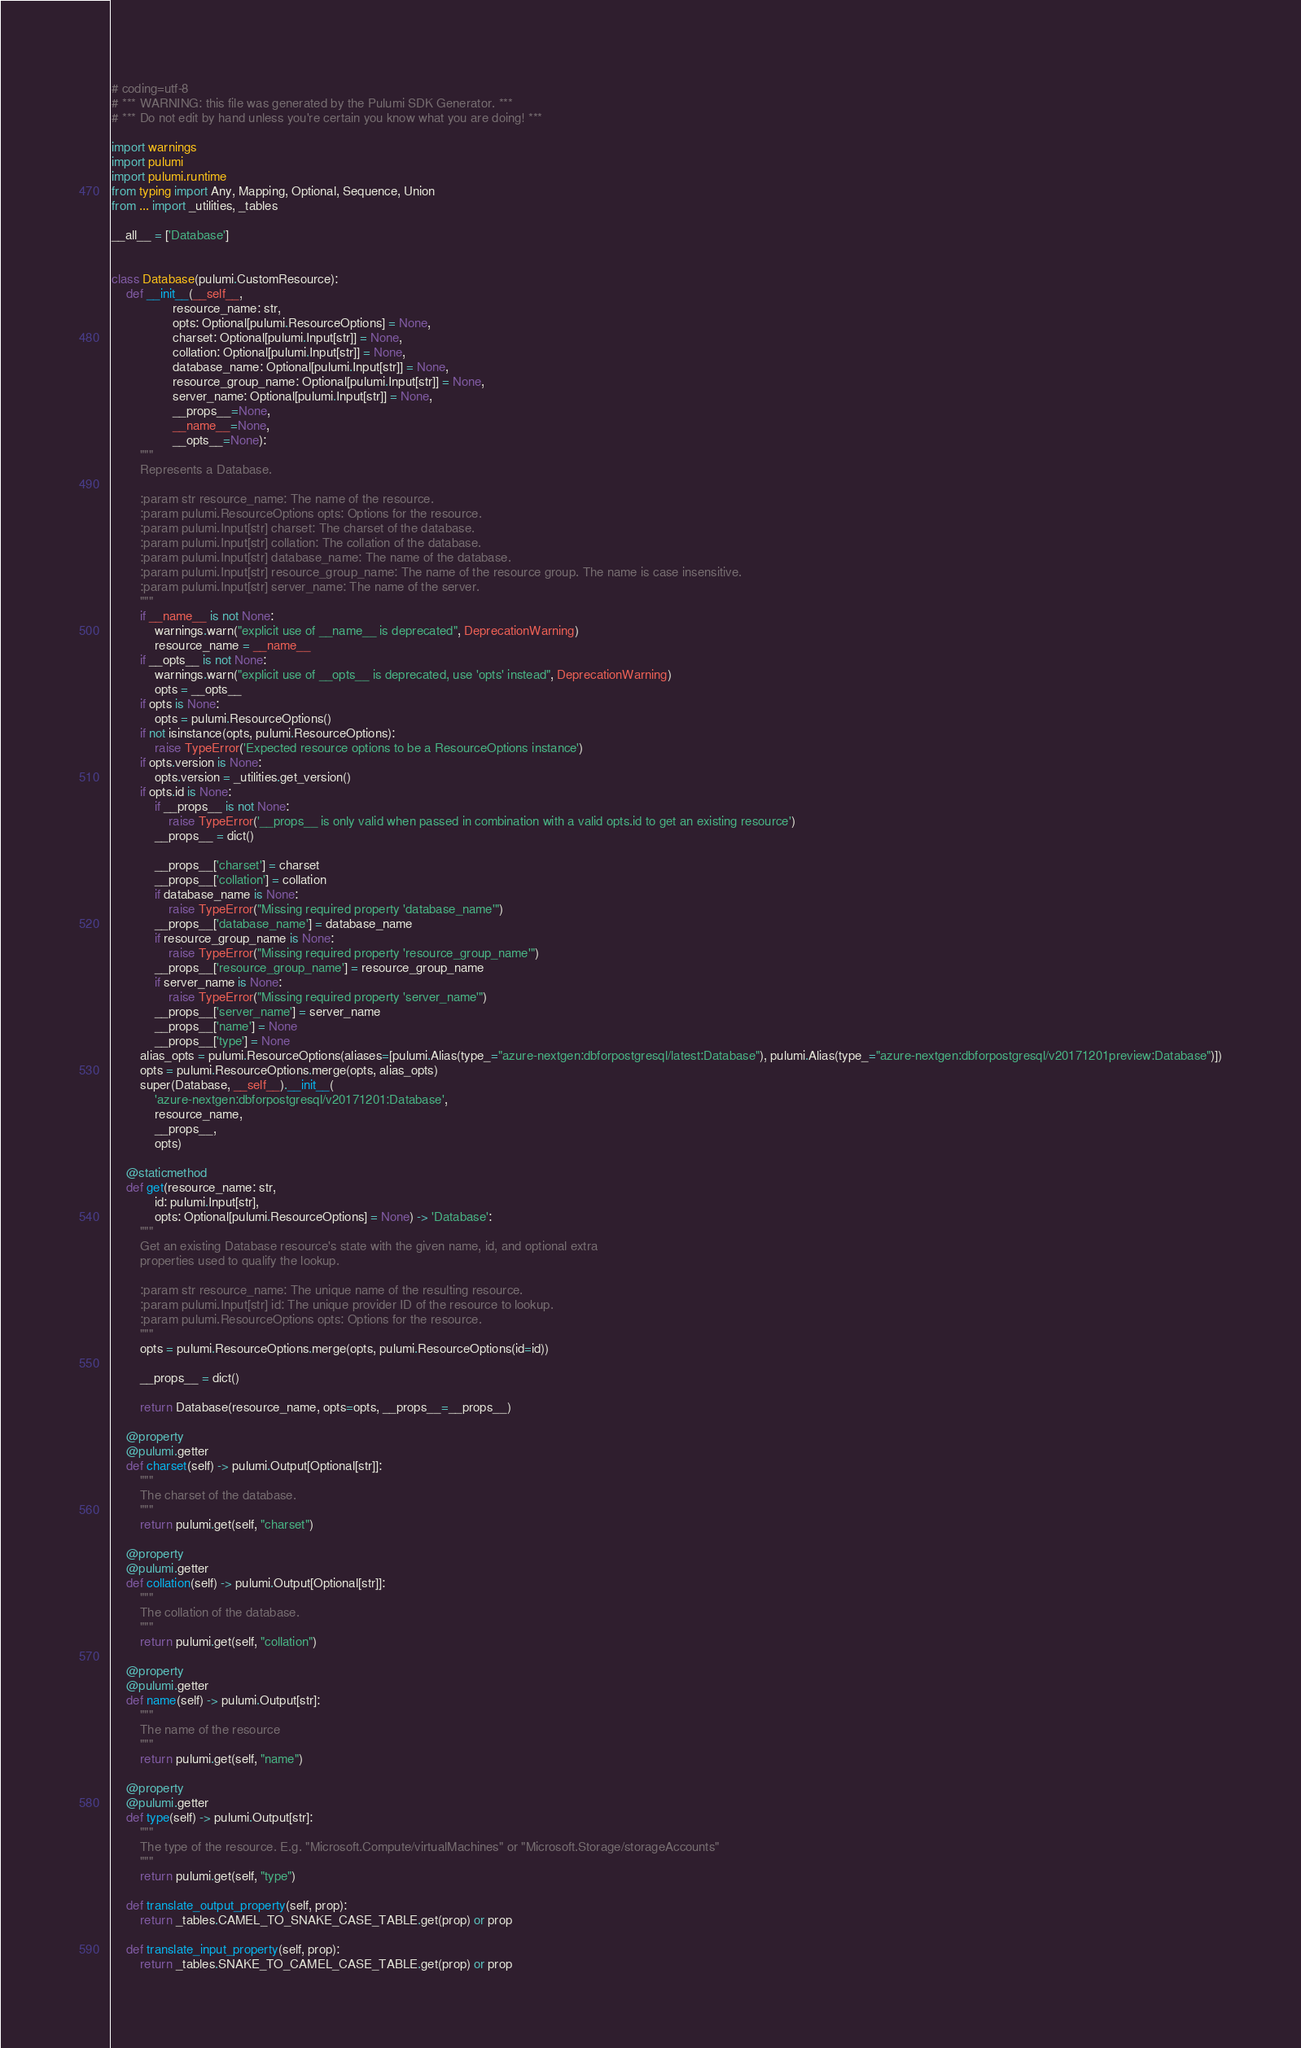<code> <loc_0><loc_0><loc_500><loc_500><_Python_># coding=utf-8
# *** WARNING: this file was generated by the Pulumi SDK Generator. ***
# *** Do not edit by hand unless you're certain you know what you are doing! ***

import warnings
import pulumi
import pulumi.runtime
from typing import Any, Mapping, Optional, Sequence, Union
from ... import _utilities, _tables

__all__ = ['Database']


class Database(pulumi.CustomResource):
    def __init__(__self__,
                 resource_name: str,
                 opts: Optional[pulumi.ResourceOptions] = None,
                 charset: Optional[pulumi.Input[str]] = None,
                 collation: Optional[pulumi.Input[str]] = None,
                 database_name: Optional[pulumi.Input[str]] = None,
                 resource_group_name: Optional[pulumi.Input[str]] = None,
                 server_name: Optional[pulumi.Input[str]] = None,
                 __props__=None,
                 __name__=None,
                 __opts__=None):
        """
        Represents a Database.

        :param str resource_name: The name of the resource.
        :param pulumi.ResourceOptions opts: Options for the resource.
        :param pulumi.Input[str] charset: The charset of the database.
        :param pulumi.Input[str] collation: The collation of the database.
        :param pulumi.Input[str] database_name: The name of the database.
        :param pulumi.Input[str] resource_group_name: The name of the resource group. The name is case insensitive.
        :param pulumi.Input[str] server_name: The name of the server.
        """
        if __name__ is not None:
            warnings.warn("explicit use of __name__ is deprecated", DeprecationWarning)
            resource_name = __name__
        if __opts__ is not None:
            warnings.warn("explicit use of __opts__ is deprecated, use 'opts' instead", DeprecationWarning)
            opts = __opts__
        if opts is None:
            opts = pulumi.ResourceOptions()
        if not isinstance(opts, pulumi.ResourceOptions):
            raise TypeError('Expected resource options to be a ResourceOptions instance')
        if opts.version is None:
            opts.version = _utilities.get_version()
        if opts.id is None:
            if __props__ is not None:
                raise TypeError('__props__ is only valid when passed in combination with a valid opts.id to get an existing resource')
            __props__ = dict()

            __props__['charset'] = charset
            __props__['collation'] = collation
            if database_name is None:
                raise TypeError("Missing required property 'database_name'")
            __props__['database_name'] = database_name
            if resource_group_name is None:
                raise TypeError("Missing required property 'resource_group_name'")
            __props__['resource_group_name'] = resource_group_name
            if server_name is None:
                raise TypeError("Missing required property 'server_name'")
            __props__['server_name'] = server_name
            __props__['name'] = None
            __props__['type'] = None
        alias_opts = pulumi.ResourceOptions(aliases=[pulumi.Alias(type_="azure-nextgen:dbforpostgresql/latest:Database"), pulumi.Alias(type_="azure-nextgen:dbforpostgresql/v20171201preview:Database")])
        opts = pulumi.ResourceOptions.merge(opts, alias_opts)
        super(Database, __self__).__init__(
            'azure-nextgen:dbforpostgresql/v20171201:Database',
            resource_name,
            __props__,
            opts)

    @staticmethod
    def get(resource_name: str,
            id: pulumi.Input[str],
            opts: Optional[pulumi.ResourceOptions] = None) -> 'Database':
        """
        Get an existing Database resource's state with the given name, id, and optional extra
        properties used to qualify the lookup.

        :param str resource_name: The unique name of the resulting resource.
        :param pulumi.Input[str] id: The unique provider ID of the resource to lookup.
        :param pulumi.ResourceOptions opts: Options for the resource.
        """
        opts = pulumi.ResourceOptions.merge(opts, pulumi.ResourceOptions(id=id))

        __props__ = dict()

        return Database(resource_name, opts=opts, __props__=__props__)

    @property
    @pulumi.getter
    def charset(self) -> pulumi.Output[Optional[str]]:
        """
        The charset of the database.
        """
        return pulumi.get(self, "charset")

    @property
    @pulumi.getter
    def collation(self) -> pulumi.Output[Optional[str]]:
        """
        The collation of the database.
        """
        return pulumi.get(self, "collation")

    @property
    @pulumi.getter
    def name(self) -> pulumi.Output[str]:
        """
        The name of the resource
        """
        return pulumi.get(self, "name")

    @property
    @pulumi.getter
    def type(self) -> pulumi.Output[str]:
        """
        The type of the resource. E.g. "Microsoft.Compute/virtualMachines" or "Microsoft.Storage/storageAccounts"
        """
        return pulumi.get(self, "type")

    def translate_output_property(self, prop):
        return _tables.CAMEL_TO_SNAKE_CASE_TABLE.get(prop) or prop

    def translate_input_property(self, prop):
        return _tables.SNAKE_TO_CAMEL_CASE_TABLE.get(prop) or prop

</code> 